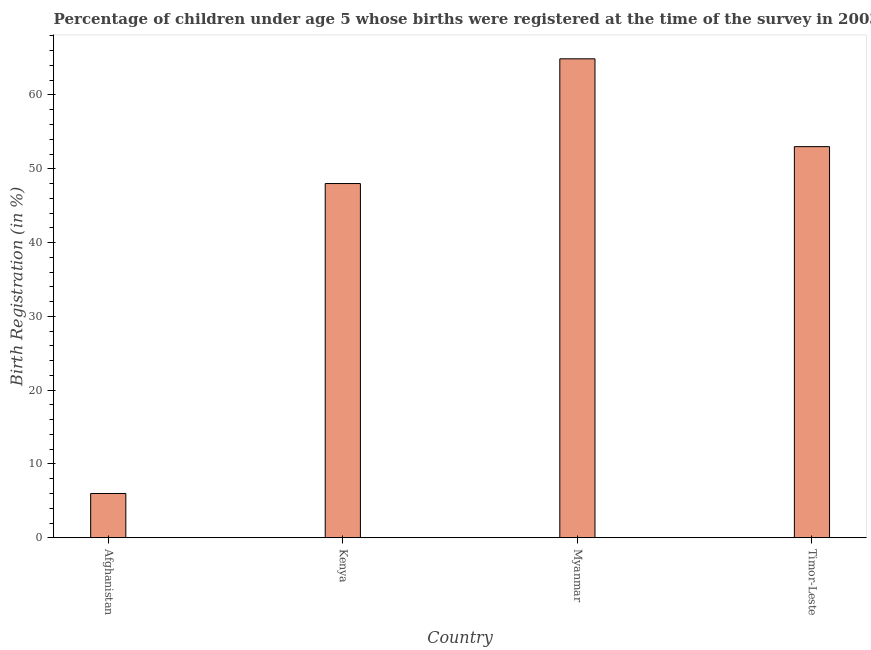Does the graph contain grids?
Make the answer very short. No. What is the title of the graph?
Keep it short and to the point. Percentage of children under age 5 whose births were registered at the time of the survey in 2003. What is the label or title of the Y-axis?
Offer a terse response. Birth Registration (in %). What is the birth registration in Myanmar?
Provide a short and direct response. 64.9. Across all countries, what is the maximum birth registration?
Offer a very short reply. 64.9. Across all countries, what is the minimum birth registration?
Your response must be concise. 6. In which country was the birth registration maximum?
Your response must be concise. Myanmar. In which country was the birth registration minimum?
Offer a very short reply. Afghanistan. What is the sum of the birth registration?
Your response must be concise. 171.9. What is the difference between the birth registration in Afghanistan and Kenya?
Your response must be concise. -42. What is the average birth registration per country?
Make the answer very short. 42.98. What is the median birth registration?
Provide a short and direct response. 50.5. In how many countries, is the birth registration greater than 30 %?
Make the answer very short. 3. What is the ratio of the birth registration in Myanmar to that in Timor-Leste?
Your answer should be very brief. 1.23. Is the difference between the birth registration in Kenya and Timor-Leste greater than the difference between any two countries?
Your answer should be very brief. No. Is the sum of the birth registration in Myanmar and Timor-Leste greater than the maximum birth registration across all countries?
Provide a succinct answer. Yes. What is the difference between the highest and the lowest birth registration?
Your response must be concise. 58.9. In how many countries, is the birth registration greater than the average birth registration taken over all countries?
Your answer should be very brief. 3. How many countries are there in the graph?
Provide a short and direct response. 4. What is the difference between two consecutive major ticks on the Y-axis?
Provide a short and direct response. 10. Are the values on the major ticks of Y-axis written in scientific E-notation?
Your answer should be very brief. No. What is the Birth Registration (in %) in Myanmar?
Provide a short and direct response. 64.9. What is the Birth Registration (in %) in Timor-Leste?
Provide a succinct answer. 53. What is the difference between the Birth Registration (in %) in Afghanistan and Kenya?
Your answer should be very brief. -42. What is the difference between the Birth Registration (in %) in Afghanistan and Myanmar?
Your response must be concise. -58.9. What is the difference between the Birth Registration (in %) in Afghanistan and Timor-Leste?
Make the answer very short. -47. What is the difference between the Birth Registration (in %) in Kenya and Myanmar?
Offer a terse response. -16.9. What is the difference between the Birth Registration (in %) in Kenya and Timor-Leste?
Offer a very short reply. -5. What is the difference between the Birth Registration (in %) in Myanmar and Timor-Leste?
Provide a succinct answer. 11.9. What is the ratio of the Birth Registration (in %) in Afghanistan to that in Kenya?
Offer a very short reply. 0.12. What is the ratio of the Birth Registration (in %) in Afghanistan to that in Myanmar?
Ensure brevity in your answer.  0.09. What is the ratio of the Birth Registration (in %) in Afghanistan to that in Timor-Leste?
Provide a short and direct response. 0.11. What is the ratio of the Birth Registration (in %) in Kenya to that in Myanmar?
Keep it short and to the point. 0.74. What is the ratio of the Birth Registration (in %) in Kenya to that in Timor-Leste?
Provide a succinct answer. 0.91. What is the ratio of the Birth Registration (in %) in Myanmar to that in Timor-Leste?
Your response must be concise. 1.23. 